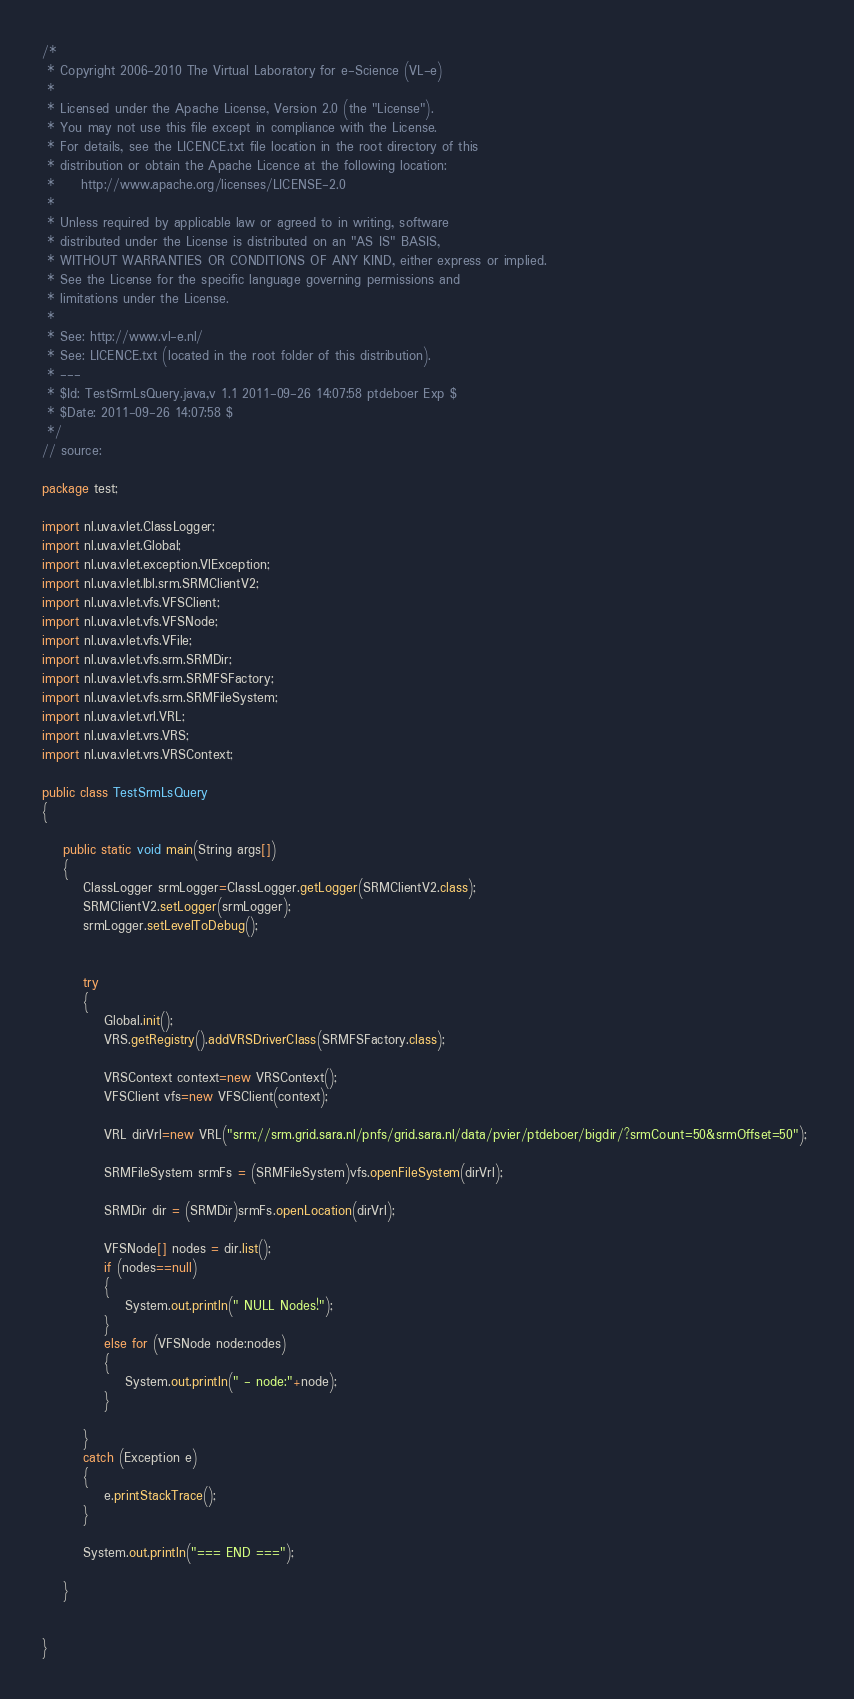<code> <loc_0><loc_0><loc_500><loc_500><_Java_>/*
 * Copyright 2006-2010 The Virtual Laboratory for e-Science (VL-e) 
 * 
 * Licensed under the Apache License, Version 2.0 (the "License").  
 * You may not use this file except in compliance with the License. 
 * For details, see the LICENCE.txt file location in the root directory of this 
 * distribution or obtain the Apache Licence at the following location: 
 *     http://www.apache.org/licenses/LICENSE-2.0
 *
 * Unless required by applicable law or agreed to in writing, software 
 * distributed under the License is distributed on an "AS IS" BASIS, 
 * WITHOUT WARRANTIES OR CONDITIONS OF ANY KIND, either express or implied. 
 * See the License for the specific language governing permissions and 
 * limitations under the License.
 * 
 * See: http://www.vl-e.nl/ 
 * See: LICENCE.txt (located in the root folder of this distribution). 
 * ---
 * $Id: TestSrmLsQuery.java,v 1.1 2011-09-26 14:07:58 ptdeboer Exp $  
 * $Date: 2011-09-26 14:07:58 $
 */ 
// source: 

package test;

import nl.uva.vlet.ClassLogger;
import nl.uva.vlet.Global;
import nl.uva.vlet.exception.VlException;
import nl.uva.vlet.lbl.srm.SRMClientV2;
import nl.uva.vlet.vfs.VFSClient;
import nl.uva.vlet.vfs.VFSNode;
import nl.uva.vlet.vfs.VFile;
import nl.uva.vlet.vfs.srm.SRMDir;
import nl.uva.vlet.vfs.srm.SRMFSFactory;
import nl.uva.vlet.vfs.srm.SRMFileSystem;
import nl.uva.vlet.vrl.VRL;
import nl.uva.vlet.vrs.VRS;
import nl.uva.vlet.vrs.VRSContext;

public class TestSrmLsQuery
{

	public static void main(String args[])
	{
	    ClassLogger srmLogger=ClassLogger.getLogger(SRMClientV2.class); 
        SRMClientV2.setLogger(srmLogger);
        srmLogger.setLevelToDebug();
        
        
		try
		{
			Global.init();
			VRS.getRegistry().addVRSDriverClass(SRMFSFactory.class);
			
		    VRSContext context=new VRSContext(); 
		    VFSClient vfs=new VFSClient(context);
		    
		    VRL dirVrl=new VRL("srm://srm.grid.sara.nl/pnfs/grid.sara.nl/data/pvier/ptdeboer/bigdir/?srmCount=50&srmOffset=50"); 

		    SRMFileSystem srmFs = (SRMFileSystem)vfs.openFileSystem(dirVrl);
		    
		    SRMDir dir = (SRMDir)srmFs.openLocation(dirVrl);
		    
		    VFSNode[] nodes = dir.list(); 
		    if (nodes==null)
		    {
		        System.out.println(" NULL Nodes!"); 
		    }
		    else for (VFSNode node:nodes)
	        {
		        System.out.println(" - node:"+node); 
	        }
		    
		}
		catch (Exception e)
		{
			e.printStackTrace();
		}
		
		System.out.println("=== END ===");
		
	}

	
}
</code> 